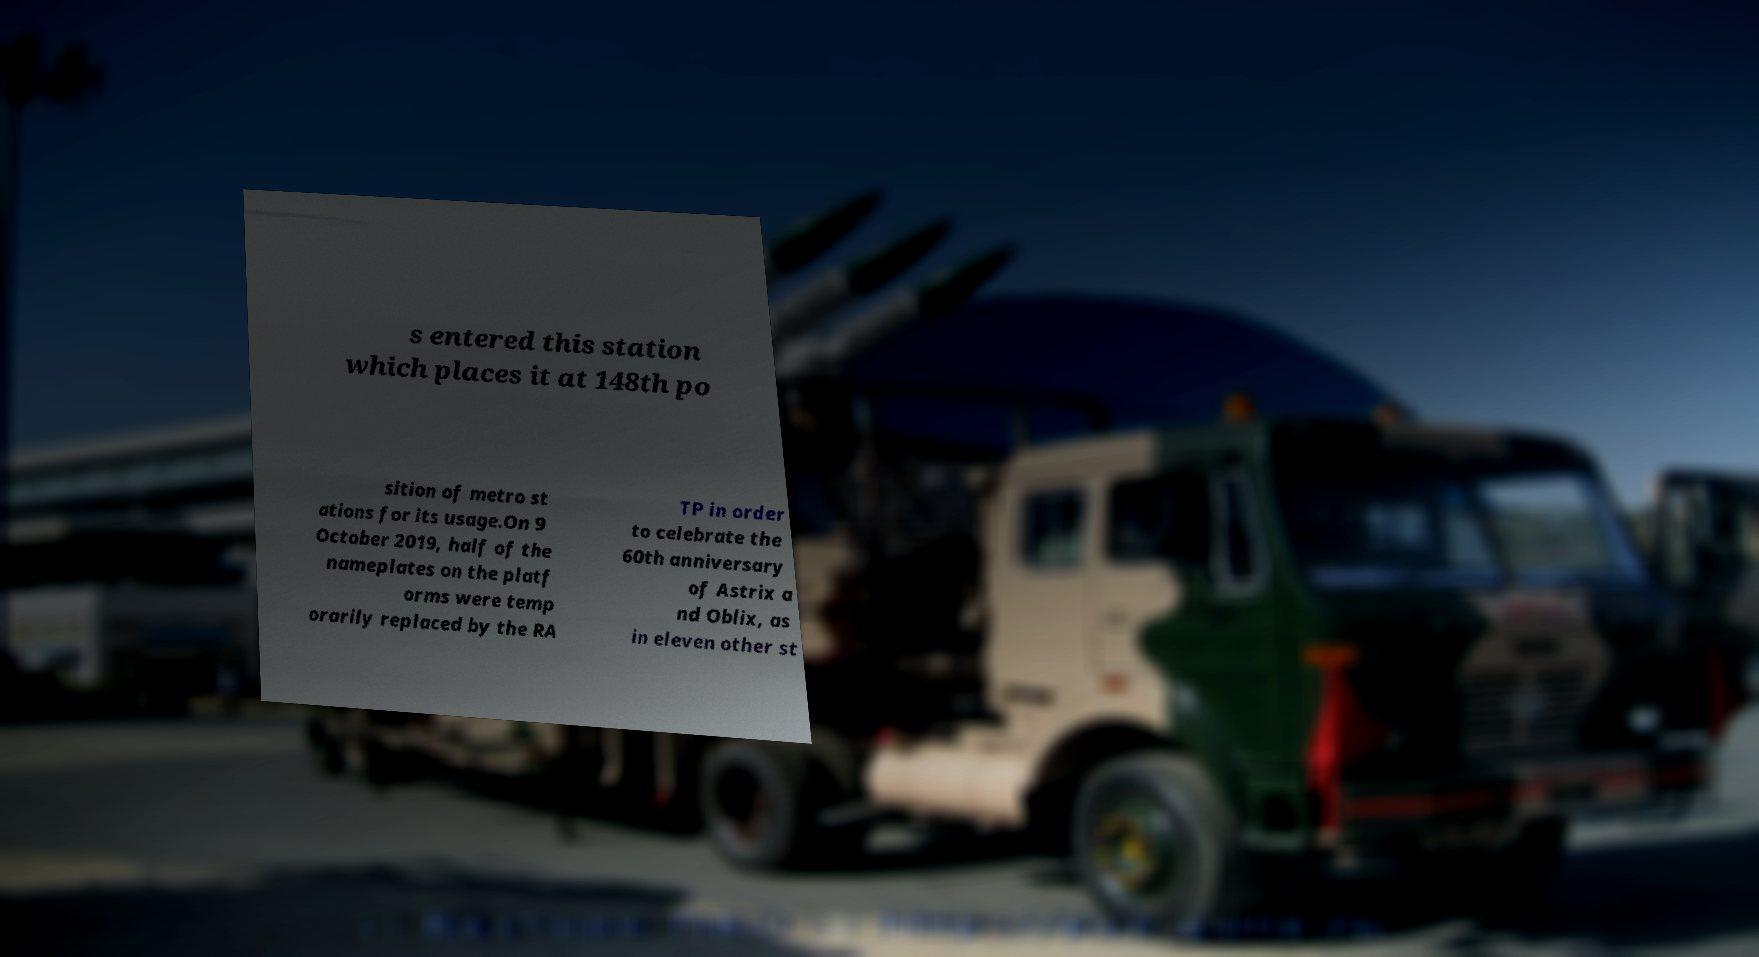Could you assist in decoding the text presented in this image and type it out clearly? s entered this station which places it at 148th po sition of metro st ations for its usage.On 9 October 2019, half of the nameplates on the platf orms were temp orarily replaced by the RA TP in order to celebrate the 60th anniversary of Astrix a nd Oblix, as in eleven other st 